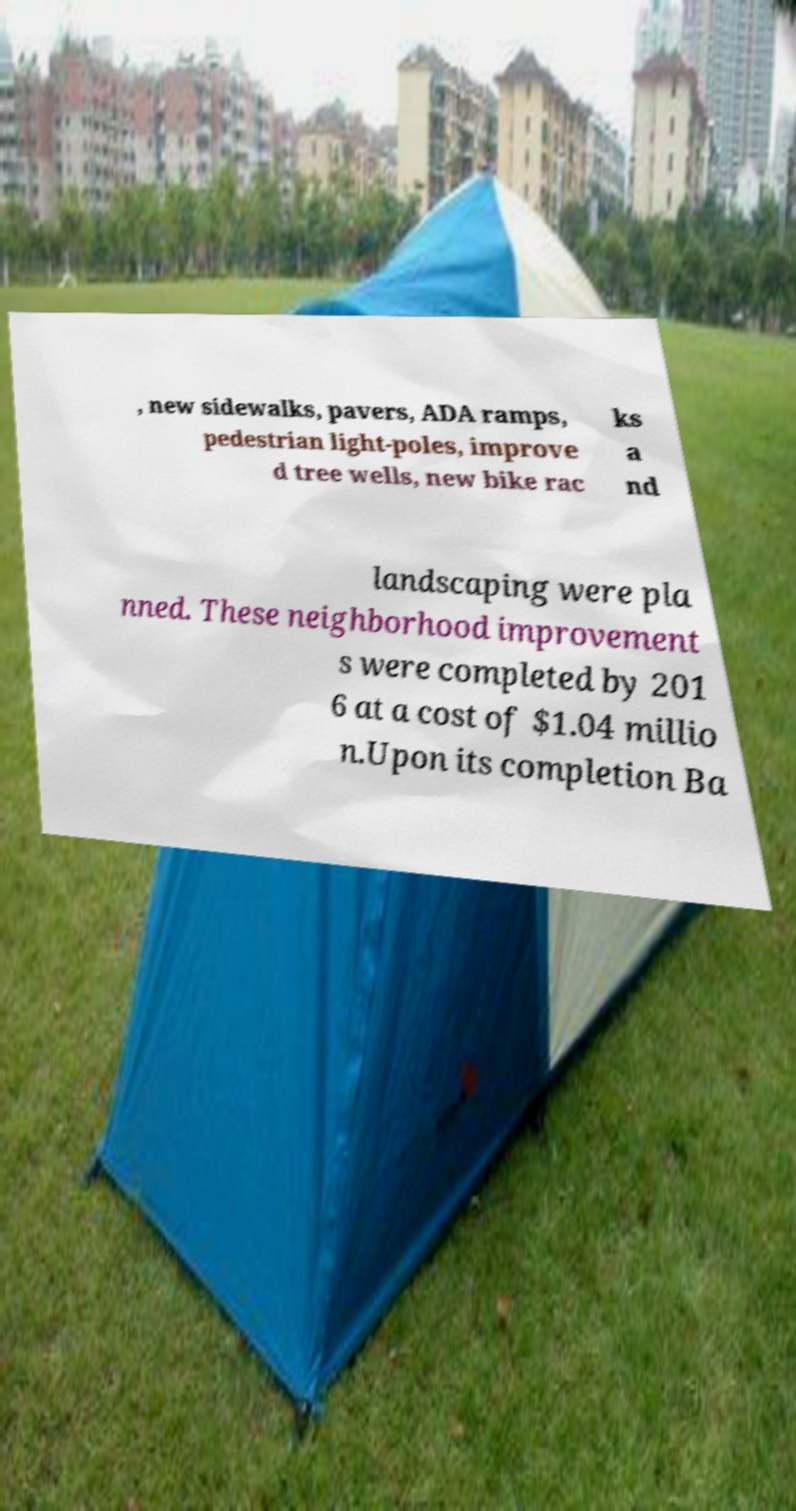Could you extract and type out the text from this image? , new sidewalks, pavers, ADA ramps, pedestrian light-poles, improve d tree wells, new bike rac ks a nd landscaping were pla nned. These neighborhood improvement s were completed by 201 6 at a cost of $1.04 millio n.Upon its completion Ba 